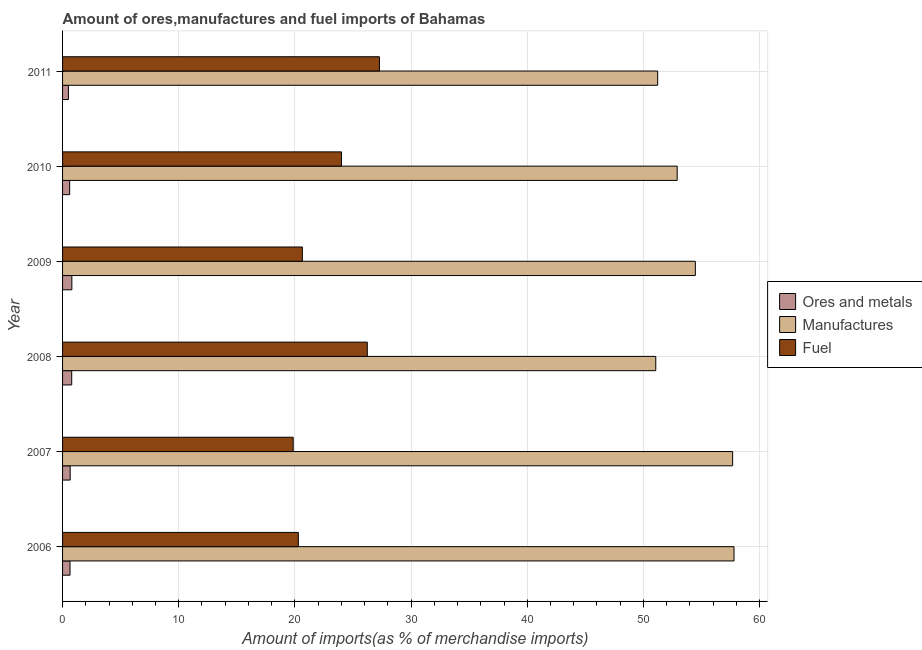How many different coloured bars are there?
Your answer should be very brief. 3. Are the number of bars per tick equal to the number of legend labels?
Offer a very short reply. Yes. Are the number of bars on each tick of the Y-axis equal?
Your response must be concise. Yes. How many bars are there on the 1st tick from the bottom?
Your answer should be very brief. 3. What is the label of the 3rd group of bars from the top?
Give a very brief answer. 2009. In how many cases, is the number of bars for a given year not equal to the number of legend labels?
Provide a short and direct response. 0. What is the percentage of manufactures imports in 2007?
Your response must be concise. 57.68. Across all years, what is the maximum percentage of fuel imports?
Offer a terse response. 27.28. Across all years, what is the minimum percentage of ores and metals imports?
Your answer should be compact. 0.5. In which year was the percentage of manufactures imports minimum?
Give a very brief answer. 2008. What is the total percentage of manufactures imports in the graph?
Your answer should be compact. 325.14. What is the difference between the percentage of ores and metals imports in 2008 and the percentage of manufactures imports in 2009?
Your answer should be very brief. -53.68. What is the average percentage of fuel imports per year?
Provide a short and direct response. 23.05. In the year 2006, what is the difference between the percentage of fuel imports and percentage of manufactures imports?
Keep it short and to the point. -37.5. What is the ratio of the percentage of manufactures imports in 2008 to that in 2011?
Offer a terse response. 1. Is the percentage of fuel imports in 2006 less than that in 2009?
Keep it short and to the point. Yes. Is the difference between the percentage of ores and metals imports in 2006 and 2011 greater than the difference between the percentage of fuel imports in 2006 and 2011?
Give a very brief answer. Yes. What is the difference between the highest and the second highest percentage of fuel imports?
Provide a short and direct response. 1.05. What is the difference between the highest and the lowest percentage of manufactures imports?
Offer a very short reply. 6.74. Is the sum of the percentage of ores and metals imports in 2006 and 2008 greater than the maximum percentage of manufactures imports across all years?
Your response must be concise. No. What does the 2nd bar from the top in 2008 represents?
Your answer should be compact. Manufactures. What does the 2nd bar from the bottom in 2008 represents?
Offer a very short reply. Manufactures. Are all the bars in the graph horizontal?
Your answer should be very brief. Yes. How many years are there in the graph?
Keep it short and to the point. 6. Are the values on the major ticks of X-axis written in scientific E-notation?
Offer a very short reply. No. Where does the legend appear in the graph?
Keep it short and to the point. Center right. How are the legend labels stacked?
Provide a short and direct response. Vertical. What is the title of the graph?
Offer a terse response. Amount of ores,manufactures and fuel imports of Bahamas. What is the label or title of the X-axis?
Your answer should be compact. Amount of imports(as % of merchandise imports). What is the label or title of the Y-axis?
Your answer should be compact. Year. What is the Amount of imports(as % of merchandise imports) in Ores and metals in 2006?
Ensure brevity in your answer.  0.64. What is the Amount of imports(as % of merchandise imports) of Manufactures in 2006?
Your answer should be compact. 57.8. What is the Amount of imports(as % of merchandise imports) in Fuel in 2006?
Offer a terse response. 20.29. What is the Amount of imports(as % of merchandise imports) of Ores and metals in 2007?
Your answer should be very brief. 0.65. What is the Amount of imports(as % of merchandise imports) of Manufactures in 2007?
Your response must be concise. 57.68. What is the Amount of imports(as % of merchandise imports) of Fuel in 2007?
Provide a succinct answer. 19.85. What is the Amount of imports(as % of merchandise imports) in Ores and metals in 2008?
Provide a succinct answer. 0.79. What is the Amount of imports(as % of merchandise imports) in Manufactures in 2008?
Ensure brevity in your answer.  51.06. What is the Amount of imports(as % of merchandise imports) in Fuel in 2008?
Your response must be concise. 26.23. What is the Amount of imports(as % of merchandise imports) in Ores and metals in 2009?
Give a very brief answer. 0.8. What is the Amount of imports(as % of merchandise imports) in Manufactures in 2009?
Offer a very short reply. 54.47. What is the Amount of imports(as % of merchandise imports) in Fuel in 2009?
Give a very brief answer. 20.64. What is the Amount of imports(as % of merchandise imports) of Ores and metals in 2010?
Ensure brevity in your answer.  0.61. What is the Amount of imports(as % of merchandise imports) of Manufactures in 2010?
Give a very brief answer. 52.91. What is the Amount of imports(as % of merchandise imports) in Fuel in 2010?
Your response must be concise. 24.01. What is the Amount of imports(as % of merchandise imports) of Ores and metals in 2011?
Make the answer very short. 0.5. What is the Amount of imports(as % of merchandise imports) of Manufactures in 2011?
Your response must be concise. 51.23. What is the Amount of imports(as % of merchandise imports) in Fuel in 2011?
Ensure brevity in your answer.  27.28. Across all years, what is the maximum Amount of imports(as % of merchandise imports) in Ores and metals?
Provide a succinct answer. 0.8. Across all years, what is the maximum Amount of imports(as % of merchandise imports) in Manufactures?
Your answer should be very brief. 57.8. Across all years, what is the maximum Amount of imports(as % of merchandise imports) of Fuel?
Offer a very short reply. 27.28. Across all years, what is the minimum Amount of imports(as % of merchandise imports) of Ores and metals?
Offer a terse response. 0.5. Across all years, what is the minimum Amount of imports(as % of merchandise imports) of Manufactures?
Provide a short and direct response. 51.06. Across all years, what is the minimum Amount of imports(as % of merchandise imports) of Fuel?
Ensure brevity in your answer.  19.85. What is the total Amount of imports(as % of merchandise imports) of Ores and metals in the graph?
Your answer should be compact. 4. What is the total Amount of imports(as % of merchandise imports) in Manufactures in the graph?
Provide a short and direct response. 325.14. What is the total Amount of imports(as % of merchandise imports) in Fuel in the graph?
Give a very brief answer. 138.3. What is the difference between the Amount of imports(as % of merchandise imports) of Ores and metals in 2006 and that in 2007?
Provide a short and direct response. -0.01. What is the difference between the Amount of imports(as % of merchandise imports) of Manufactures in 2006 and that in 2007?
Your response must be concise. 0.12. What is the difference between the Amount of imports(as % of merchandise imports) of Fuel in 2006 and that in 2007?
Ensure brevity in your answer.  0.44. What is the difference between the Amount of imports(as % of merchandise imports) in Ores and metals in 2006 and that in 2008?
Your answer should be compact. -0.15. What is the difference between the Amount of imports(as % of merchandise imports) in Manufactures in 2006 and that in 2008?
Your response must be concise. 6.74. What is the difference between the Amount of imports(as % of merchandise imports) in Fuel in 2006 and that in 2008?
Offer a very short reply. -5.94. What is the difference between the Amount of imports(as % of merchandise imports) of Ores and metals in 2006 and that in 2009?
Your response must be concise. -0.16. What is the difference between the Amount of imports(as % of merchandise imports) in Manufactures in 2006 and that in 2009?
Make the answer very short. 3.33. What is the difference between the Amount of imports(as % of merchandise imports) in Fuel in 2006 and that in 2009?
Offer a terse response. -0.35. What is the difference between the Amount of imports(as % of merchandise imports) of Ores and metals in 2006 and that in 2010?
Offer a very short reply. 0.03. What is the difference between the Amount of imports(as % of merchandise imports) in Manufactures in 2006 and that in 2010?
Keep it short and to the point. 4.89. What is the difference between the Amount of imports(as % of merchandise imports) of Fuel in 2006 and that in 2010?
Provide a succinct answer. -3.72. What is the difference between the Amount of imports(as % of merchandise imports) of Ores and metals in 2006 and that in 2011?
Make the answer very short. 0.14. What is the difference between the Amount of imports(as % of merchandise imports) in Manufactures in 2006 and that in 2011?
Provide a succinct answer. 6.57. What is the difference between the Amount of imports(as % of merchandise imports) in Fuel in 2006 and that in 2011?
Offer a terse response. -6.98. What is the difference between the Amount of imports(as % of merchandise imports) of Ores and metals in 2007 and that in 2008?
Ensure brevity in your answer.  -0.13. What is the difference between the Amount of imports(as % of merchandise imports) of Manufactures in 2007 and that in 2008?
Offer a very short reply. 6.62. What is the difference between the Amount of imports(as % of merchandise imports) of Fuel in 2007 and that in 2008?
Make the answer very short. -6.38. What is the difference between the Amount of imports(as % of merchandise imports) of Ores and metals in 2007 and that in 2009?
Provide a short and direct response. -0.15. What is the difference between the Amount of imports(as % of merchandise imports) of Manufactures in 2007 and that in 2009?
Give a very brief answer. 3.21. What is the difference between the Amount of imports(as % of merchandise imports) in Fuel in 2007 and that in 2009?
Ensure brevity in your answer.  -0.79. What is the difference between the Amount of imports(as % of merchandise imports) in Ores and metals in 2007 and that in 2010?
Your answer should be very brief. 0.04. What is the difference between the Amount of imports(as % of merchandise imports) of Manufactures in 2007 and that in 2010?
Make the answer very short. 4.77. What is the difference between the Amount of imports(as % of merchandise imports) in Fuel in 2007 and that in 2010?
Provide a short and direct response. -4.16. What is the difference between the Amount of imports(as % of merchandise imports) in Ores and metals in 2007 and that in 2011?
Keep it short and to the point. 0.15. What is the difference between the Amount of imports(as % of merchandise imports) in Manufactures in 2007 and that in 2011?
Make the answer very short. 6.45. What is the difference between the Amount of imports(as % of merchandise imports) in Fuel in 2007 and that in 2011?
Make the answer very short. -7.43. What is the difference between the Amount of imports(as % of merchandise imports) in Ores and metals in 2008 and that in 2009?
Keep it short and to the point. -0.01. What is the difference between the Amount of imports(as % of merchandise imports) in Manufactures in 2008 and that in 2009?
Offer a terse response. -3.41. What is the difference between the Amount of imports(as % of merchandise imports) in Fuel in 2008 and that in 2009?
Provide a short and direct response. 5.59. What is the difference between the Amount of imports(as % of merchandise imports) of Ores and metals in 2008 and that in 2010?
Ensure brevity in your answer.  0.18. What is the difference between the Amount of imports(as % of merchandise imports) in Manufactures in 2008 and that in 2010?
Keep it short and to the point. -1.84. What is the difference between the Amount of imports(as % of merchandise imports) in Fuel in 2008 and that in 2010?
Keep it short and to the point. 2.22. What is the difference between the Amount of imports(as % of merchandise imports) of Ores and metals in 2008 and that in 2011?
Provide a succinct answer. 0.28. What is the difference between the Amount of imports(as % of merchandise imports) in Manufactures in 2008 and that in 2011?
Your answer should be compact. -0.16. What is the difference between the Amount of imports(as % of merchandise imports) of Fuel in 2008 and that in 2011?
Give a very brief answer. -1.05. What is the difference between the Amount of imports(as % of merchandise imports) in Ores and metals in 2009 and that in 2010?
Provide a short and direct response. 0.19. What is the difference between the Amount of imports(as % of merchandise imports) in Manufactures in 2009 and that in 2010?
Provide a short and direct response. 1.56. What is the difference between the Amount of imports(as % of merchandise imports) in Fuel in 2009 and that in 2010?
Ensure brevity in your answer.  -3.37. What is the difference between the Amount of imports(as % of merchandise imports) in Ores and metals in 2009 and that in 2011?
Ensure brevity in your answer.  0.3. What is the difference between the Amount of imports(as % of merchandise imports) of Manufactures in 2009 and that in 2011?
Your answer should be very brief. 3.24. What is the difference between the Amount of imports(as % of merchandise imports) in Fuel in 2009 and that in 2011?
Keep it short and to the point. -6.63. What is the difference between the Amount of imports(as % of merchandise imports) of Ores and metals in 2010 and that in 2011?
Offer a terse response. 0.11. What is the difference between the Amount of imports(as % of merchandise imports) in Manufactures in 2010 and that in 2011?
Make the answer very short. 1.68. What is the difference between the Amount of imports(as % of merchandise imports) of Fuel in 2010 and that in 2011?
Your response must be concise. -3.27. What is the difference between the Amount of imports(as % of merchandise imports) of Ores and metals in 2006 and the Amount of imports(as % of merchandise imports) of Manufactures in 2007?
Your answer should be very brief. -57.04. What is the difference between the Amount of imports(as % of merchandise imports) in Ores and metals in 2006 and the Amount of imports(as % of merchandise imports) in Fuel in 2007?
Give a very brief answer. -19.21. What is the difference between the Amount of imports(as % of merchandise imports) of Manufactures in 2006 and the Amount of imports(as % of merchandise imports) of Fuel in 2007?
Keep it short and to the point. 37.95. What is the difference between the Amount of imports(as % of merchandise imports) of Ores and metals in 2006 and the Amount of imports(as % of merchandise imports) of Manufactures in 2008?
Your response must be concise. -50.42. What is the difference between the Amount of imports(as % of merchandise imports) of Ores and metals in 2006 and the Amount of imports(as % of merchandise imports) of Fuel in 2008?
Your response must be concise. -25.59. What is the difference between the Amount of imports(as % of merchandise imports) in Manufactures in 2006 and the Amount of imports(as % of merchandise imports) in Fuel in 2008?
Provide a short and direct response. 31.57. What is the difference between the Amount of imports(as % of merchandise imports) in Ores and metals in 2006 and the Amount of imports(as % of merchandise imports) in Manufactures in 2009?
Your answer should be very brief. -53.83. What is the difference between the Amount of imports(as % of merchandise imports) in Ores and metals in 2006 and the Amount of imports(as % of merchandise imports) in Fuel in 2009?
Offer a very short reply. -20. What is the difference between the Amount of imports(as % of merchandise imports) of Manufactures in 2006 and the Amount of imports(as % of merchandise imports) of Fuel in 2009?
Give a very brief answer. 37.16. What is the difference between the Amount of imports(as % of merchandise imports) in Ores and metals in 2006 and the Amount of imports(as % of merchandise imports) in Manufactures in 2010?
Keep it short and to the point. -52.26. What is the difference between the Amount of imports(as % of merchandise imports) in Ores and metals in 2006 and the Amount of imports(as % of merchandise imports) in Fuel in 2010?
Ensure brevity in your answer.  -23.37. What is the difference between the Amount of imports(as % of merchandise imports) of Manufactures in 2006 and the Amount of imports(as % of merchandise imports) of Fuel in 2010?
Provide a succinct answer. 33.79. What is the difference between the Amount of imports(as % of merchandise imports) of Ores and metals in 2006 and the Amount of imports(as % of merchandise imports) of Manufactures in 2011?
Ensure brevity in your answer.  -50.58. What is the difference between the Amount of imports(as % of merchandise imports) of Ores and metals in 2006 and the Amount of imports(as % of merchandise imports) of Fuel in 2011?
Ensure brevity in your answer.  -26.64. What is the difference between the Amount of imports(as % of merchandise imports) in Manufactures in 2006 and the Amount of imports(as % of merchandise imports) in Fuel in 2011?
Provide a short and direct response. 30.52. What is the difference between the Amount of imports(as % of merchandise imports) in Ores and metals in 2007 and the Amount of imports(as % of merchandise imports) in Manufactures in 2008?
Provide a succinct answer. -50.41. What is the difference between the Amount of imports(as % of merchandise imports) in Ores and metals in 2007 and the Amount of imports(as % of merchandise imports) in Fuel in 2008?
Provide a succinct answer. -25.58. What is the difference between the Amount of imports(as % of merchandise imports) in Manufactures in 2007 and the Amount of imports(as % of merchandise imports) in Fuel in 2008?
Provide a succinct answer. 31.45. What is the difference between the Amount of imports(as % of merchandise imports) in Ores and metals in 2007 and the Amount of imports(as % of merchandise imports) in Manufactures in 2009?
Your answer should be very brief. -53.81. What is the difference between the Amount of imports(as % of merchandise imports) in Ores and metals in 2007 and the Amount of imports(as % of merchandise imports) in Fuel in 2009?
Your response must be concise. -19.99. What is the difference between the Amount of imports(as % of merchandise imports) of Manufactures in 2007 and the Amount of imports(as % of merchandise imports) of Fuel in 2009?
Your response must be concise. 37.04. What is the difference between the Amount of imports(as % of merchandise imports) of Ores and metals in 2007 and the Amount of imports(as % of merchandise imports) of Manufactures in 2010?
Your response must be concise. -52.25. What is the difference between the Amount of imports(as % of merchandise imports) in Ores and metals in 2007 and the Amount of imports(as % of merchandise imports) in Fuel in 2010?
Your response must be concise. -23.36. What is the difference between the Amount of imports(as % of merchandise imports) of Manufactures in 2007 and the Amount of imports(as % of merchandise imports) of Fuel in 2010?
Make the answer very short. 33.67. What is the difference between the Amount of imports(as % of merchandise imports) of Ores and metals in 2007 and the Amount of imports(as % of merchandise imports) of Manufactures in 2011?
Your response must be concise. -50.57. What is the difference between the Amount of imports(as % of merchandise imports) of Ores and metals in 2007 and the Amount of imports(as % of merchandise imports) of Fuel in 2011?
Make the answer very short. -26.62. What is the difference between the Amount of imports(as % of merchandise imports) in Manufactures in 2007 and the Amount of imports(as % of merchandise imports) in Fuel in 2011?
Provide a succinct answer. 30.4. What is the difference between the Amount of imports(as % of merchandise imports) in Ores and metals in 2008 and the Amount of imports(as % of merchandise imports) in Manufactures in 2009?
Your answer should be compact. -53.68. What is the difference between the Amount of imports(as % of merchandise imports) of Ores and metals in 2008 and the Amount of imports(as % of merchandise imports) of Fuel in 2009?
Provide a short and direct response. -19.85. What is the difference between the Amount of imports(as % of merchandise imports) in Manufactures in 2008 and the Amount of imports(as % of merchandise imports) in Fuel in 2009?
Ensure brevity in your answer.  30.42. What is the difference between the Amount of imports(as % of merchandise imports) of Ores and metals in 2008 and the Amount of imports(as % of merchandise imports) of Manufactures in 2010?
Your answer should be very brief. -52.12. What is the difference between the Amount of imports(as % of merchandise imports) in Ores and metals in 2008 and the Amount of imports(as % of merchandise imports) in Fuel in 2010?
Keep it short and to the point. -23.22. What is the difference between the Amount of imports(as % of merchandise imports) in Manufactures in 2008 and the Amount of imports(as % of merchandise imports) in Fuel in 2010?
Offer a very short reply. 27.05. What is the difference between the Amount of imports(as % of merchandise imports) of Ores and metals in 2008 and the Amount of imports(as % of merchandise imports) of Manufactures in 2011?
Your response must be concise. -50.44. What is the difference between the Amount of imports(as % of merchandise imports) in Ores and metals in 2008 and the Amount of imports(as % of merchandise imports) in Fuel in 2011?
Your answer should be compact. -26.49. What is the difference between the Amount of imports(as % of merchandise imports) in Manufactures in 2008 and the Amount of imports(as % of merchandise imports) in Fuel in 2011?
Provide a succinct answer. 23.79. What is the difference between the Amount of imports(as % of merchandise imports) of Ores and metals in 2009 and the Amount of imports(as % of merchandise imports) of Manufactures in 2010?
Make the answer very short. -52.11. What is the difference between the Amount of imports(as % of merchandise imports) of Ores and metals in 2009 and the Amount of imports(as % of merchandise imports) of Fuel in 2010?
Keep it short and to the point. -23.21. What is the difference between the Amount of imports(as % of merchandise imports) in Manufactures in 2009 and the Amount of imports(as % of merchandise imports) in Fuel in 2010?
Give a very brief answer. 30.46. What is the difference between the Amount of imports(as % of merchandise imports) of Ores and metals in 2009 and the Amount of imports(as % of merchandise imports) of Manufactures in 2011?
Provide a short and direct response. -50.43. What is the difference between the Amount of imports(as % of merchandise imports) of Ores and metals in 2009 and the Amount of imports(as % of merchandise imports) of Fuel in 2011?
Your answer should be very brief. -26.48. What is the difference between the Amount of imports(as % of merchandise imports) of Manufactures in 2009 and the Amount of imports(as % of merchandise imports) of Fuel in 2011?
Make the answer very short. 27.19. What is the difference between the Amount of imports(as % of merchandise imports) in Ores and metals in 2010 and the Amount of imports(as % of merchandise imports) in Manufactures in 2011?
Your answer should be compact. -50.61. What is the difference between the Amount of imports(as % of merchandise imports) in Ores and metals in 2010 and the Amount of imports(as % of merchandise imports) in Fuel in 2011?
Make the answer very short. -26.67. What is the difference between the Amount of imports(as % of merchandise imports) of Manufactures in 2010 and the Amount of imports(as % of merchandise imports) of Fuel in 2011?
Your answer should be compact. 25.63. What is the average Amount of imports(as % of merchandise imports) in Ores and metals per year?
Your answer should be very brief. 0.67. What is the average Amount of imports(as % of merchandise imports) in Manufactures per year?
Your answer should be compact. 54.19. What is the average Amount of imports(as % of merchandise imports) of Fuel per year?
Offer a terse response. 23.05. In the year 2006, what is the difference between the Amount of imports(as % of merchandise imports) of Ores and metals and Amount of imports(as % of merchandise imports) of Manufactures?
Make the answer very short. -57.16. In the year 2006, what is the difference between the Amount of imports(as % of merchandise imports) of Ores and metals and Amount of imports(as % of merchandise imports) of Fuel?
Offer a very short reply. -19.65. In the year 2006, what is the difference between the Amount of imports(as % of merchandise imports) in Manufactures and Amount of imports(as % of merchandise imports) in Fuel?
Offer a very short reply. 37.5. In the year 2007, what is the difference between the Amount of imports(as % of merchandise imports) of Ores and metals and Amount of imports(as % of merchandise imports) of Manufactures?
Provide a short and direct response. -57.02. In the year 2007, what is the difference between the Amount of imports(as % of merchandise imports) in Ores and metals and Amount of imports(as % of merchandise imports) in Fuel?
Make the answer very short. -19.2. In the year 2007, what is the difference between the Amount of imports(as % of merchandise imports) of Manufactures and Amount of imports(as % of merchandise imports) of Fuel?
Provide a succinct answer. 37.83. In the year 2008, what is the difference between the Amount of imports(as % of merchandise imports) of Ores and metals and Amount of imports(as % of merchandise imports) of Manufactures?
Your answer should be compact. -50.27. In the year 2008, what is the difference between the Amount of imports(as % of merchandise imports) in Ores and metals and Amount of imports(as % of merchandise imports) in Fuel?
Provide a short and direct response. -25.44. In the year 2008, what is the difference between the Amount of imports(as % of merchandise imports) of Manufactures and Amount of imports(as % of merchandise imports) of Fuel?
Your answer should be compact. 24.83. In the year 2009, what is the difference between the Amount of imports(as % of merchandise imports) in Ores and metals and Amount of imports(as % of merchandise imports) in Manufactures?
Provide a short and direct response. -53.67. In the year 2009, what is the difference between the Amount of imports(as % of merchandise imports) of Ores and metals and Amount of imports(as % of merchandise imports) of Fuel?
Your response must be concise. -19.84. In the year 2009, what is the difference between the Amount of imports(as % of merchandise imports) of Manufactures and Amount of imports(as % of merchandise imports) of Fuel?
Make the answer very short. 33.83. In the year 2010, what is the difference between the Amount of imports(as % of merchandise imports) in Ores and metals and Amount of imports(as % of merchandise imports) in Manufactures?
Provide a short and direct response. -52.29. In the year 2010, what is the difference between the Amount of imports(as % of merchandise imports) of Ores and metals and Amount of imports(as % of merchandise imports) of Fuel?
Your response must be concise. -23.4. In the year 2010, what is the difference between the Amount of imports(as % of merchandise imports) of Manufactures and Amount of imports(as % of merchandise imports) of Fuel?
Offer a very short reply. 28.9. In the year 2011, what is the difference between the Amount of imports(as % of merchandise imports) in Ores and metals and Amount of imports(as % of merchandise imports) in Manufactures?
Make the answer very short. -50.72. In the year 2011, what is the difference between the Amount of imports(as % of merchandise imports) in Ores and metals and Amount of imports(as % of merchandise imports) in Fuel?
Offer a terse response. -26.77. In the year 2011, what is the difference between the Amount of imports(as % of merchandise imports) of Manufactures and Amount of imports(as % of merchandise imports) of Fuel?
Keep it short and to the point. 23.95. What is the ratio of the Amount of imports(as % of merchandise imports) in Ores and metals in 2006 to that in 2007?
Make the answer very short. 0.98. What is the ratio of the Amount of imports(as % of merchandise imports) of Manufactures in 2006 to that in 2007?
Provide a succinct answer. 1. What is the ratio of the Amount of imports(as % of merchandise imports) in Fuel in 2006 to that in 2007?
Make the answer very short. 1.02. What is the ratio of the Amount of imports(as % of merchandise imports) in Ores and metals in 2006 to that in 2008?
Provide a succinct answer. 0.81. What is the ratio of the Amount of imports(as % of merchandise imports) of Manufactures in 2006 to that in 2008?
Give a very brief answer. 1.13. What is the ratio of the Amount of imports(as % of merchandise imports) of Fuel in 2006 to that in 2008?
Your response must be concise. 0.77. What is the ratio of the Amount of imports(as % of merchandise imports) in Ores and metals in 2006 to that in 2009?
Keep it short and to the point. 0.8. What is the ratio of the Amount of imports(as % of merchandise imports) of Manufactures in 2006 to that in 2009?
Keep it short and to the point. 1.06. What is the ratio of the Amount of imports(as % of merchandise imports) of Fuel in 2006 to that in 2009?
Provide a short and direct response. 0.98. What is the ratio of the Amount of imports(as % of merchandise imports) of Ores and metals in 2006 to that in 2010?
Give a very brief answer. 1.05. What is the ratio of the Amount of imports(as % of merchandise imports) in Manufactures in 2006 to that in 2010?
Your answer should be very brief. 1.09. What is the ratio of the Amount of imports(as % of merchandise imports) in Fuel in 2006 to that in 2010?
Provide a short and direct response. 0.85. What is the ratio of the Amount of imports(as % of merchandise imports) in Ores and metals in 2006 to that in 2011?
Provide a succinct answer. 1.27. What is the ratio of the Amount of imports(as % of merchandise imports) in Manufactures in 2006 to that in 2011?
Make the answer very short. 1.13. What is the ratio of the Amount of imports(as % of merchandise imports) of Fuel in 2006 to that in 2011?
Ensure brevity in your answer.  0.74. What is the ratio of the Amount of imports(as % of merchandise imports) of Ores and metals in 2007 to that in 2008?
Your answer should be very brief. 0.83. What is the ratio of the Amount of imports(as % of merchandise imports) of Manufactures in 2007 to that in 2008?
Your answer should be compact. 1.13. What is the ratio of the Amount of imports(as % of merchandise imports) of Fuel in 2007 to that in 2008?
Give a very brief answer. 0.76. What is the ratio of the Amount of imports(as % of merchandise imports) of Ores and metals in 2007 to that in 2009?
Provide a short and direct response. 0.82. What is the ratio of the Amount of imports(as % of merchandise imports) of Manufactures in 2007 to that in 2009?
Offer a very short reply. 1.06. What is the ratio of the Amount of imports(as % of merchandise imports) of Fuel in 2007 to that in 2009?
Your response must be concise. 0.96. What is the ratio of the Amount of imports(as % of merchandise imports) of Ores and metals in 2007 to that in 2010?
Give a very brief answer. 1.07. What is the ratio of the Amount of imports(as % of merchandise imports) in Manufactures in 2007 to that in 2010?
Your answer should be very brief. 1.09. What is the ratio of the Amount of imports(as % of merchandise imports) of Fuel in 2007 to that in 2010?
Provide a succinct answer. 0.83. What is the ratio of the Amount of imports(as % of merchandise imports) of Ores and metals in 2007 to that in 2011?
Give a very brief answer. 1.3. What is the ratio of the Amount of imports(as % of merchandise imports) of Manufactures in 2007 to that in 2011?
Provide a succinct answer. 1.13. What is the ratio of the Amount of imports(as % of merchandise imports) in Fuel in 2007 to that in 2011?
Provide a short and direct response. 0.73. What is the ratio of the Amount of imports(as % of merchandise imports) of Ores and metals in 2008 to that in 2009?
Make the answer very short. 0.98. What is the ratio of the Amount of imports(as % of merchandise imports) of Fuel in 2008 to that in 2009?
Provide a short and direct response. 1.27. What is the ratio of the Amount of imports(as % of merchandise imports) of Ores and metals in 2008 to that in 2010?
Your response must be concise. 1.29. What is the ratio of the Amount of imports(as % of merchandise imports) in Manufactures in 2008 to that in 2010?
Provide a succinct answer. 0.97. What is the ratio of the Amount of imports(as % of merchandise imports) in Fuel in 2008 to that in 2010?
Make the answer very short. 1.09. What is the ratio of the Amount of imports(as % of merchandise imports) in Ores and metals in 2008 to that in 2011?
Provide a short and direct response. 1.56. What is the ratio of the Amount of imports(as % of merchandise imports) of Manufactures in 2008 to that in 2011?
Your answer should be compact. 1. What is the ratio of the Amount of imports(as % of merchandise imports) of Fuel in 2008 to that in 2011?
Provide a short and direct response. 0.96. What is the ratio of the Amount of imports(as % of merchandise imports) in Ores and metals in 2009 to that in 2010?
Offer a very short reply. 1.31. What is the ratio of the Amount of imports(as % of merchandise imports) of Manufactures in 2009 to that in 2010?
Provide a succinct answer. 1.03. What is the ratio of the Amount of imports(as % of merchandise imports) in Fuel in 2009 to that in 2010?
Give a very brief answer. 0.86. What is the ratio of the Amount of imports(as % of merchandise imports) in Ores and metals in 2009 to that in 2011?
Give a very brief answer. 1.59. What is the ratio of the Amount of imports(as % of merchandise imports) in Manufactures in 2009 to that in 2011?
Provide a short and direct response. 1.06. What is the ratio of the Amount of imports(as % of merchandise imports) in Fuel in 2009 to that in 2011?
Give a very brief answer. 0.76. What is the ratio of the Amount of imports(as % of merchandise imports) of Ores and metals in 2010 to that in 2011?
Your answer should be very brief. 1.21. What is the ratio of the Amount of imports(as % of merchandise imports) of Manufactures in 2010 to that in 2011?
Your answer should be very brief. 1.03. What is the ratio of the Amount of imports(as % of merchandise imports) of Fuel in 2010 to that in 2011?
Your response must be concise. 0.88. What is the difference between the highest and the second highest Amount of imports(as % of merchandise imports) of Ores and metals?
Your answer should be very brief. 0.01. What is the difference between the highest and the second highest Amount of imports(as % of merchandise imports) of Manufactures?
Offer a very short reply. 0.12. What is the difference between the highest and the second highest Amount of imports(as % of merchandise imports) of Fuel?
Your answer should be compact. 1.05. What is the difference between the highest and the lowest Amount of imports(as % of merchandise imports) of Ores and metals?
Keep it short and to the point. 0.3. What is the difference between the highest and the lowest Amount of imports(as % of merchandise imports) in Manufactures?
Give a very brief answer. 6.74. What is the difference between the highest and the lowest Amount of imports(as % of merchandise imports) in Fuel?
Make the answer very short. 7.43. 